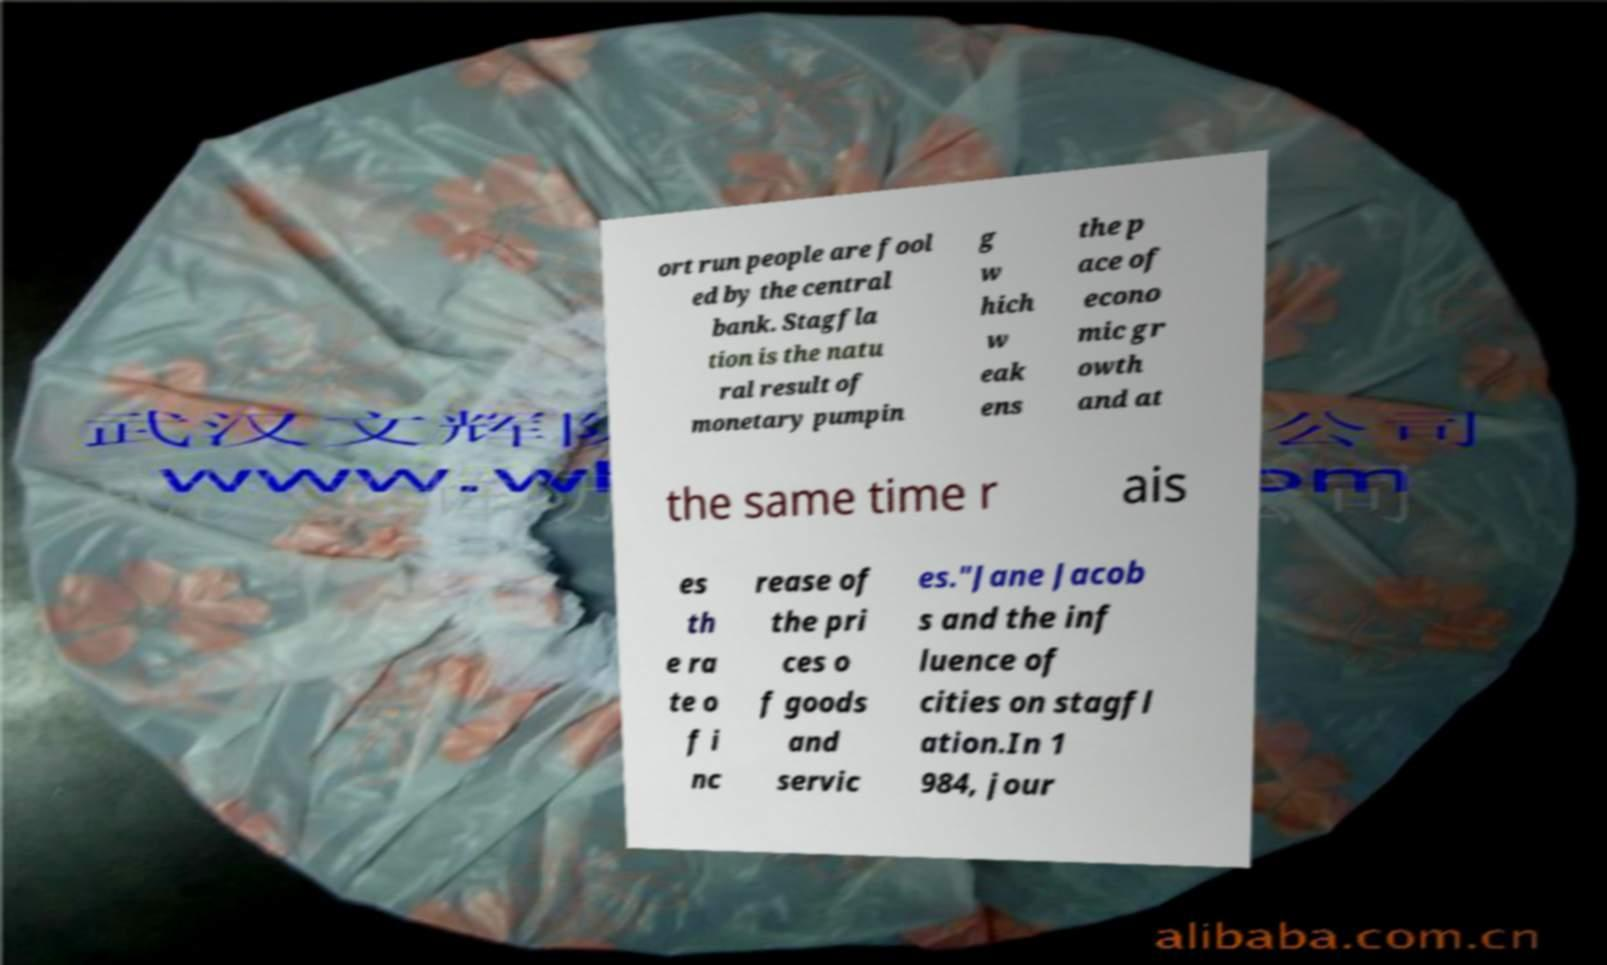Please identify and transcribe the text found in this image. ort run people are fool ed by the central bank. Stagfla tion is the natu ral result of monetary pumpin g w hich w eak ens the p ace of econo mic gr owth and at the same time r ais es th e ra te o f i nc rease of the pri ces o f goods and servic es."Jane Jacob s and the inf luence of cities on stagfl ation.In 1 984, jour 